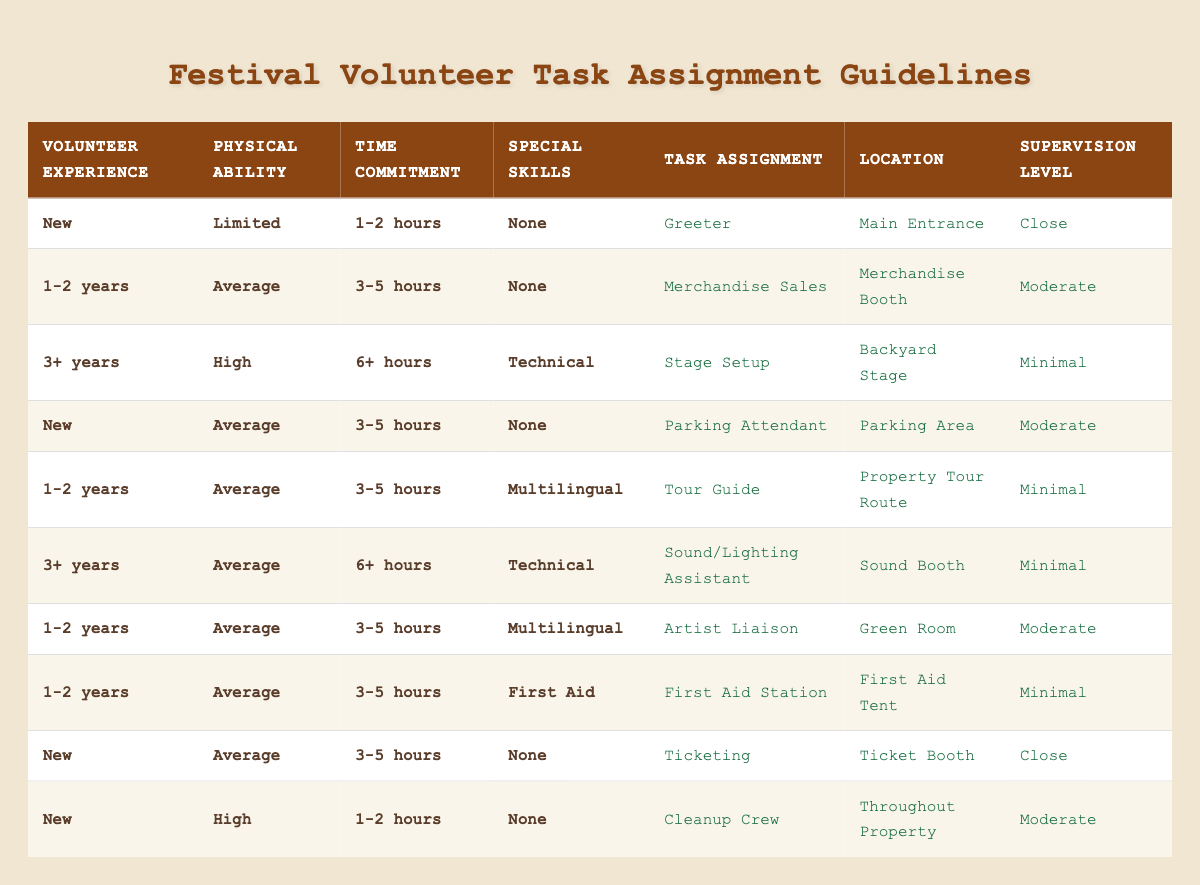What task is assigned to a volunteer with no special skills, limited physical ability, and a time commitment of 1-2 hours? By looking at the conditions, the corresponding task for "New" volunteers with "Limited" physical ability, "1-2 hours" of time commitment, and "None" for special skills is listed in the table as "Greeter."
Answer: Greeter Is there a task for volunteers with 3+ years of experience who have high physical ability and no special skills? Checking the table reveals no entries for volunteers with "3+ years" of experience, "High" physical ability, and "None" special skills, meaning there is no corresponding task assignment.
Answer: No What location is assigned to a volunteer who is a Tour Guide? Referring to the table, the task of "Tour Guide" is associated with the location "Property Tour Route."
Answer: Property Tour Route How many different tasks are assigned to volunteers with 1-2 years of experience? By searching through the table, there are four distinct tasks ("Merchandise Sales," "Artist Liaison," "Tour Guide," and "First Aid Station") tied to volunteers with "1-2 years" of experience, indicating that volunteers in this category have multiple potential roles.
Answer: 4 If a volunteer with 3+ years of experience works 6+ hours and has technical skills, what supervision level will they have? The table states that for volunteers fitting the criteria of "3+ years," "High" physical ability, "6+ hours," and "Technical," the supervision level assigned is "Minimal."
Answer: Minimal What is the average supervision level across all tasks listed? The supervision levels are "Close," "Moderate," and "Minimal," making it necessary to assign values (Close = 1, Moderate = 2, Minimal = 3) to calculate the average. Counting the occurrences yields two "Close," three "Moderate," and four "Minimal." Hence, (2*1 + 3*2 + 4*3)/9 = 2.11, rounded gives around "Moderate."
Answer: Moderate Is there a task for a new volunteer with average physical ability and a time commitment of more than 3 hours? According to the table, a new volunteer with "Average" physical ability and a commitment of "3-5 hours," does not find a specific task assignment that fits; however, they can be assigned tasks such as "Parking Attendant."
Answer: Yes What is the supervision level for a volunteer assigned to the First Aid Station? The table states that for a volunteer assigned to the "First Aid Station," the supervision level is "Minimal."
Answer: Minimal How many tasks are available for new volunteers with high physical ability? There is one task assigned to new volunteers with "High" physical ability, which is "Cleanup Crew."
Answer: 1 